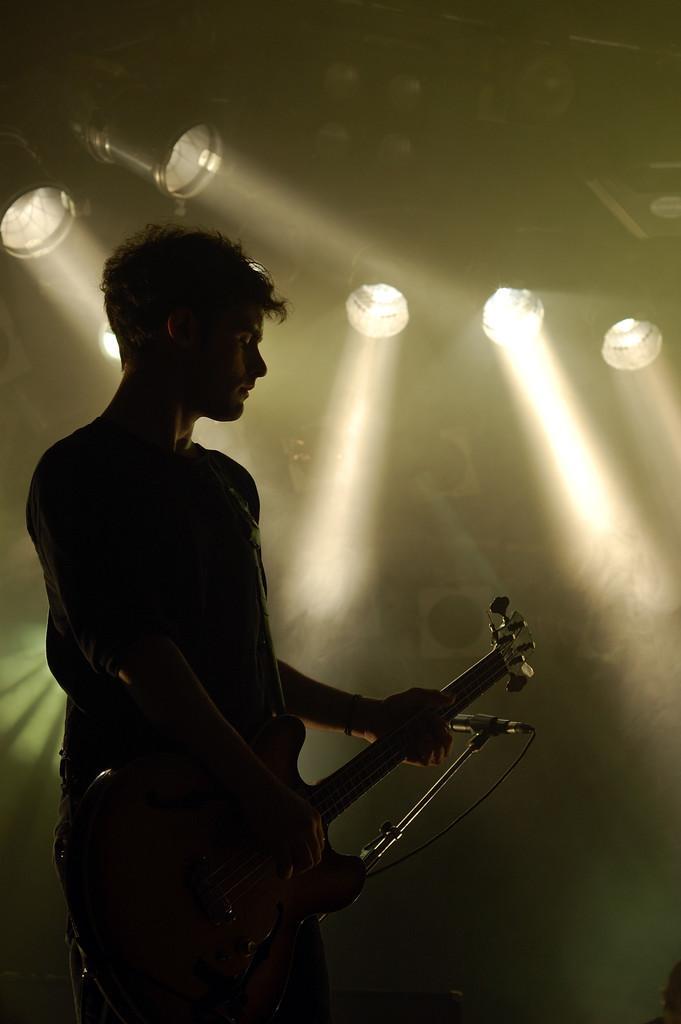Could you give a brief overview of what you see in this image? This is a picture of a man standing on stage, the man is holding a guitar in front of the man there is a microphone with stand. Behind the man their are lights and smoke. 